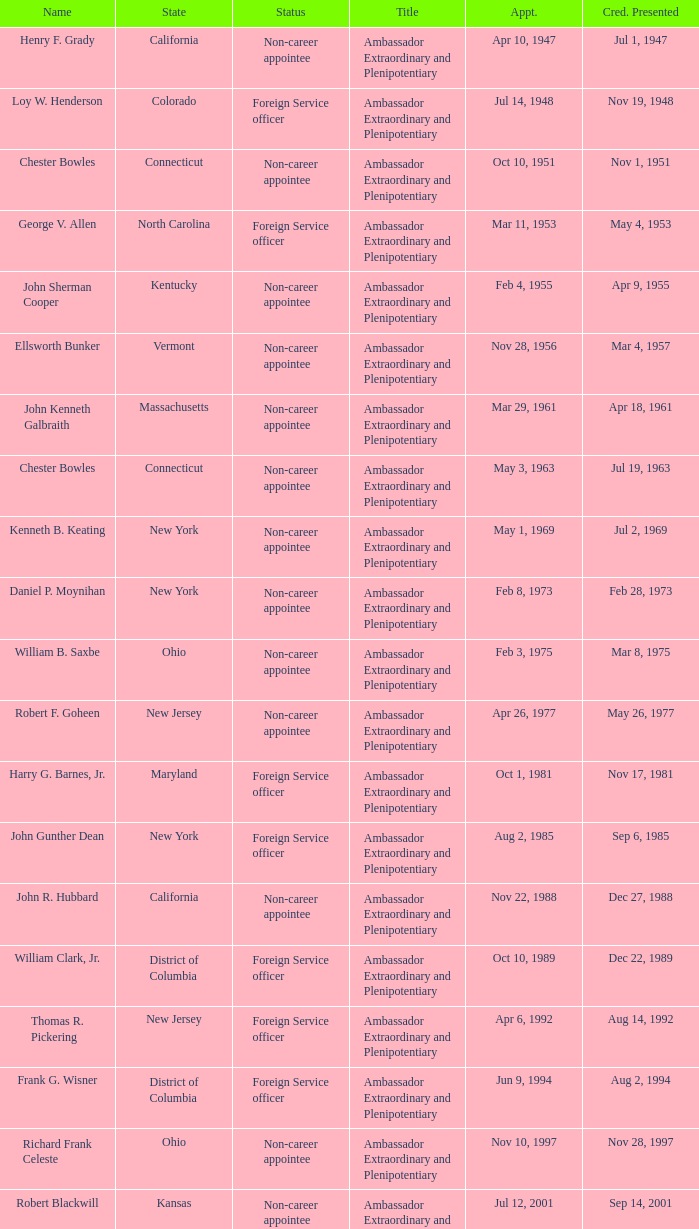What state has an appointment for jul 12, 2001? Kansas. 